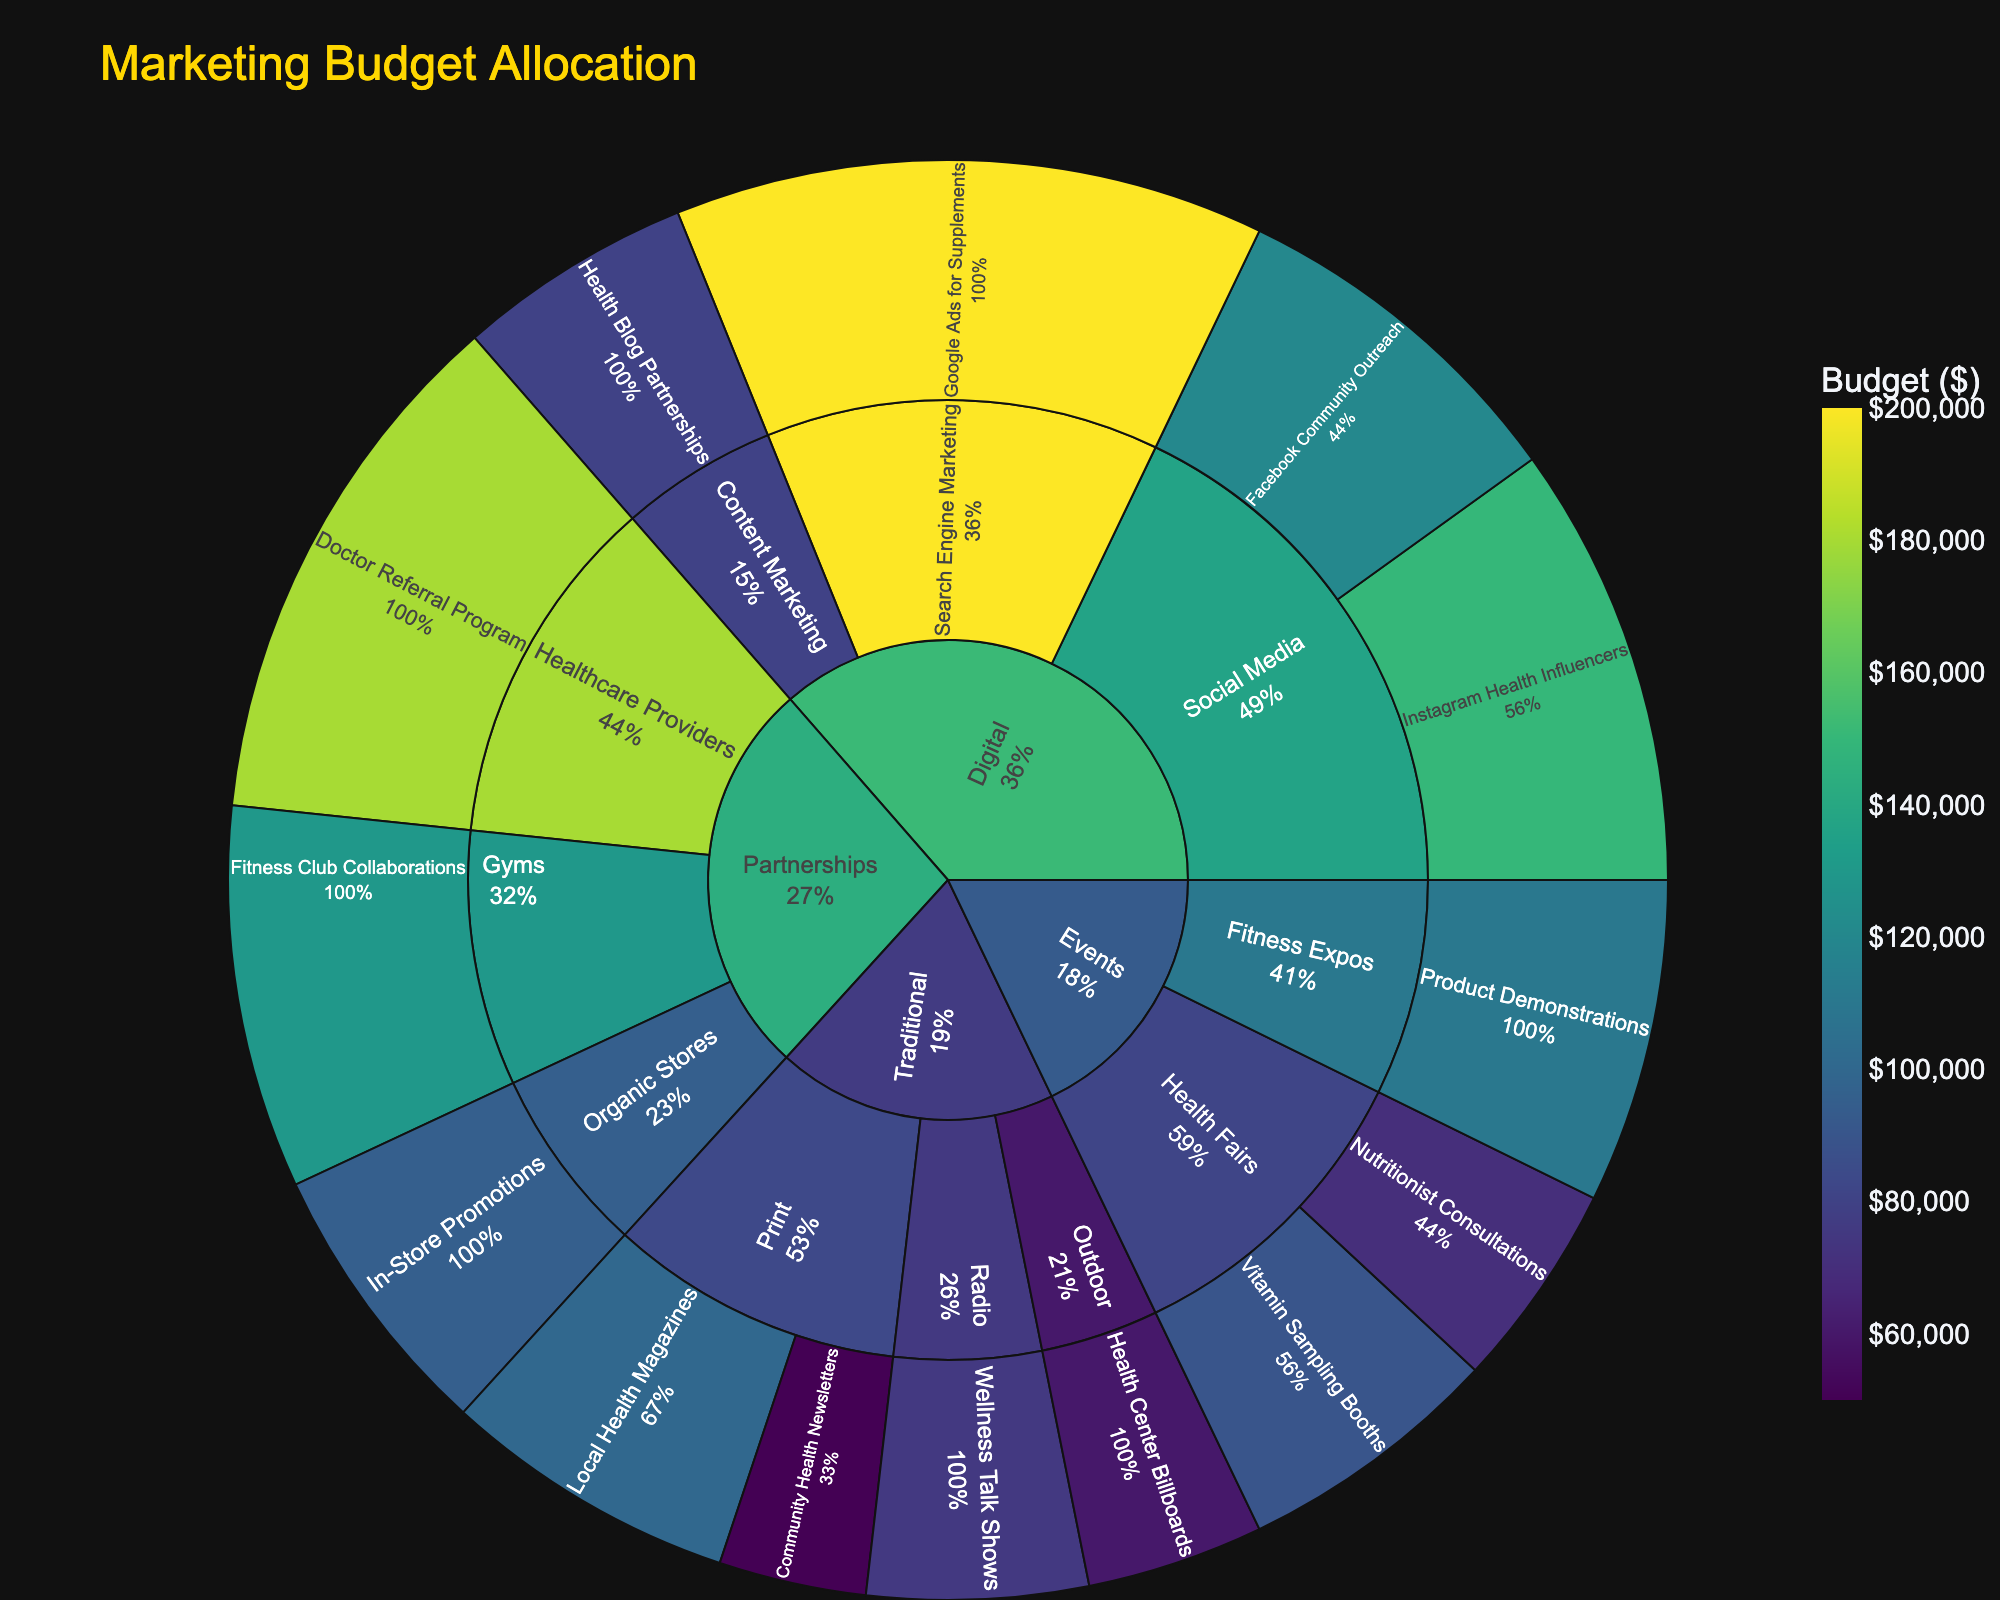What is the title of the sunburst plot? The title of the sunburst plot is usually displayed prominently at the top of the figure. In this case, it is set to "Marketing Budget Allocation."
Answer: Marketing Budget Allocation Which digital marketing subchannel has the highest budget? To find the highest budget within the digital marketing subchannels, check the figure for the 'Digital' segment and compare the budgets for Social Media, Search Engine Marketing, and Content Marketing.
Answer: Search Engine Marketing What percentage of the total budget is allocated to events? The sunburst plot shows segments with their respective percentages to their parent or the total. Locate the 'Events' segment and read the percentage associated with it.
Answer: 14.81% How does the budget for Digital Social Media compare to Partnerships with Healthcare Providers? To compare, look at the budget values for Digital Social Media (Instagram Health Influencers + Facebook Community Outreach) and Partnerships with Healthcare Providers. The sum for Social Media is 270,000, and for Healthcare Providers, it is 180,000.
Answer: Digital Social Media has a higher budget What are the two campaigns under the 'Fitness Expos' subchannel? Navigate to the 'Events' channel and then look under 'Fitness Expos' to identify the specific campaigns listed.
Answer: Product Demonstrations Which campaign in the 'Traditional' channel has the lowest budget? Within the 'Traditional' channel, compare all budget values of the Print, Radio, and Outdoor campaigns. The one with the lowest budget should be noted.
Answer: Community Health Newsletters How much budget is allocated collectively to all outdoor campaigns within the Traditional channel? Sum up the budget values listed under the 'Outdoor' subchannel within the Traditional channel. Here, it only contains Health Center Billboards.
Answer: $60,000 Which channel has the highest total budget, and what is its value? Identify the main channels (Digital, Traditional, Events, Partnerships) and compare their summed budgets. The Digital channel has the highest total.
Answer: Digital, $550,000 If Digital's budget were reduced by 20%, what would be the new total budget for the Digital channel? Calculate 20% of Digital's total budget (which is $550,000), then subtract that value from the original total.
Answer: $440,000 (after reducing $110,000) How does the budget for Partnerships compare to the budget for Traditional channels? Add the budgets allocated to all campaigns under Partnerships and compare with the summed budget of all Traditional campaigns. Here, Partnerships total $405,000 and Traditional totals $285,000.
Answer: Partnerships have a higher budget 